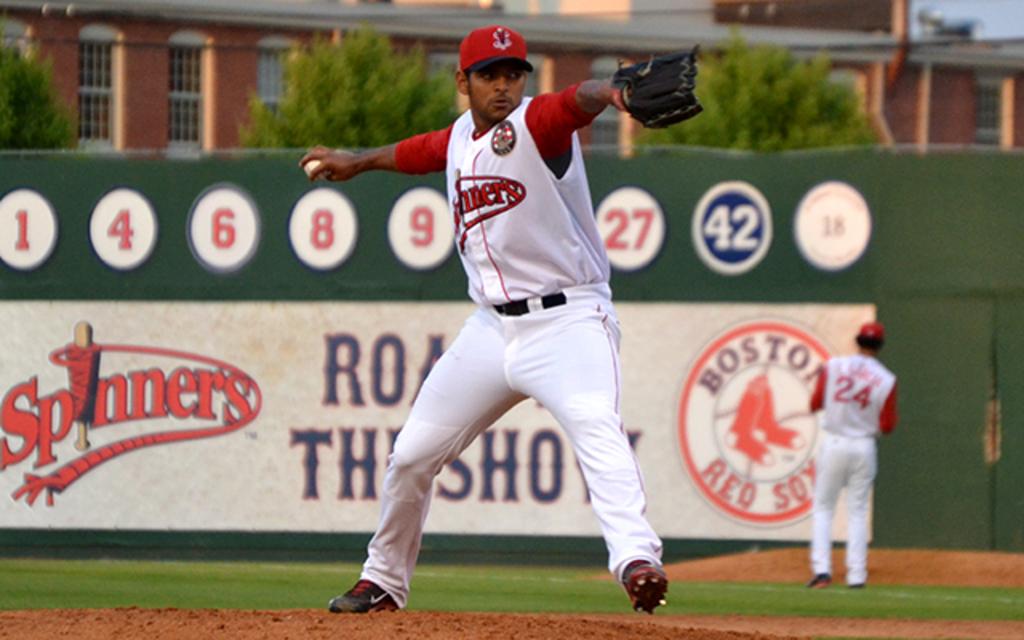What is the player number of the man near the wall?
Provide a short and direct response. 24. Which number is highlighted in blue on the wall?
Offer a terse response. 42. 